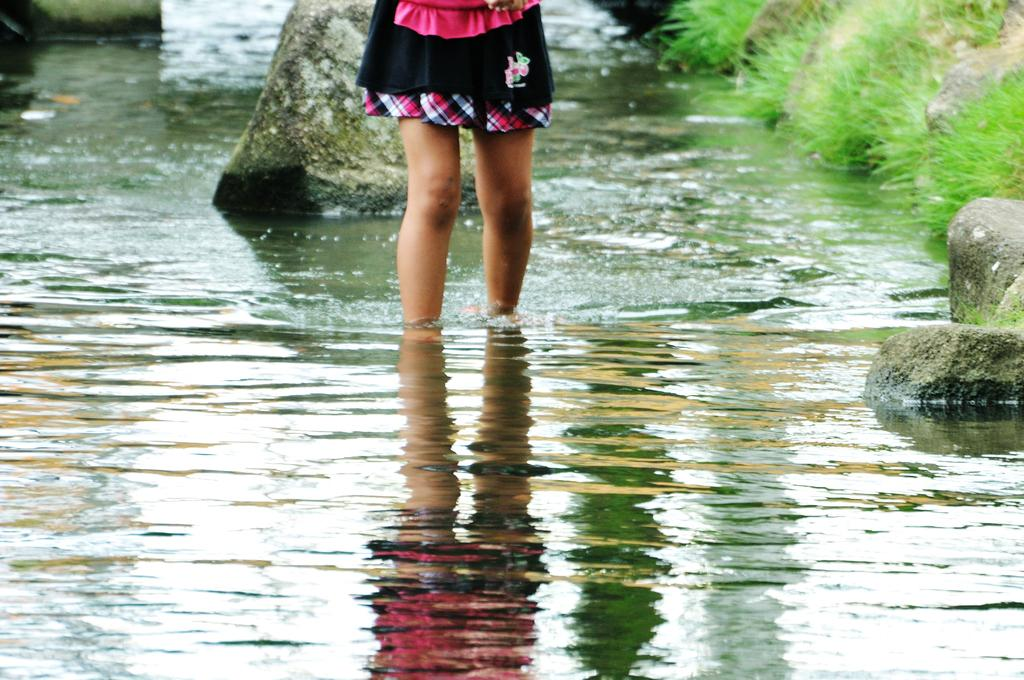What is the primary element in the image? There is water in the image. What can be seen within the water? There are rocks in the water. Whose legs are visible in the image? A girl's legs are visible in the image. What type of vegetation is present in the image? There is grass present in the image. What type of bed can be seen in the image? There is no bed present in the image; it features water, rocks, a girl's legs, and grass. 